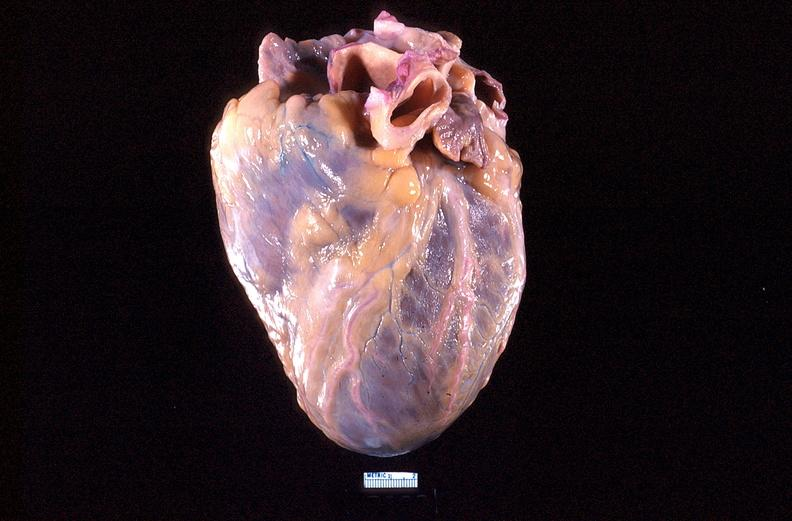s cardiovascular present?
Answer the question using a single word or phrase. Yes 